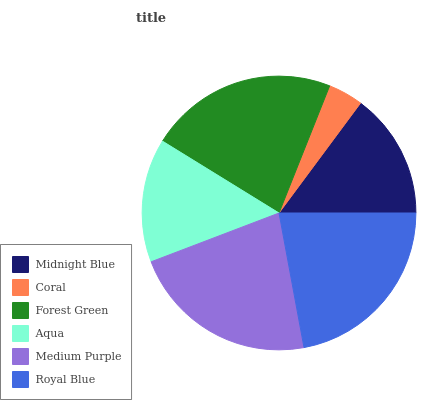Is Coral the minimum?
Answer yes or no. Yes. Is Forest Green the maximum?
Answer yes or no. Yes. Is Forest Green the minimum?
Answer yes or no. No. Is Coral the maximum?
Answer yes or no. No. Is Forest Green greater than Coral?
Answer yes or no. Yes. Is Coral less than Forest Green?
Answer yes or no. Yes. Is Coral greater than Forest Green?
Answer yes or no. No. Is Forest Green less than Coral?
Answer yes or no. No. Is Royal Blue the high median?
Answer yes or no. Yes. Is Midnight Blue the low median?
Answer yes or no. Yes. Is Coral the high median?
Answer yes or no. No. Is Medium Purple the low median?
Answer yes or no. No. 